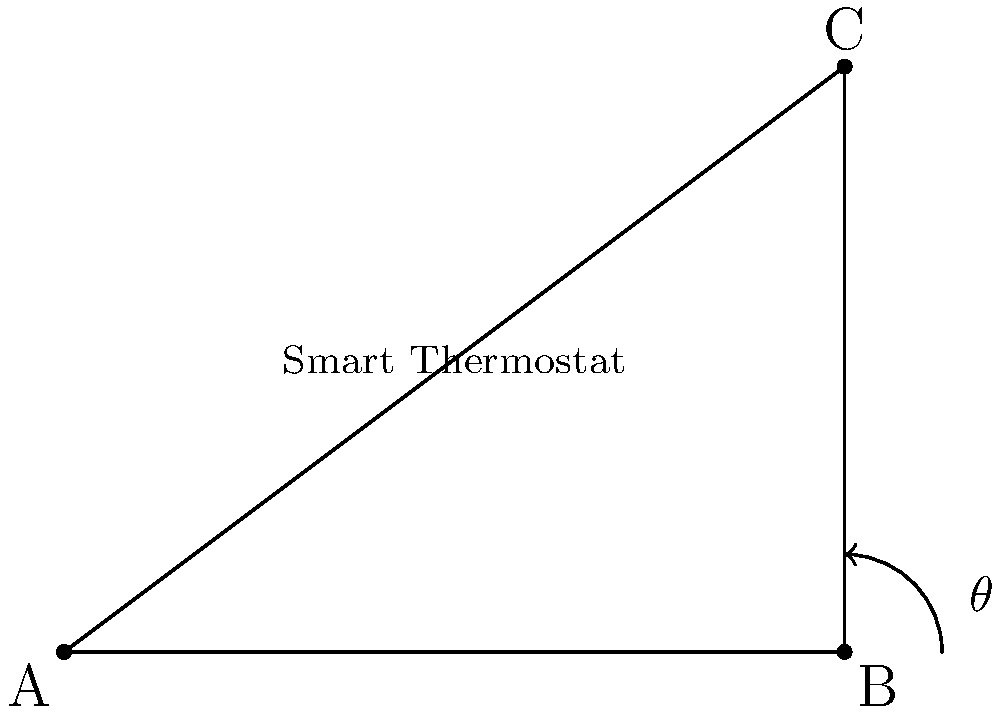In your shared apartment, a smart thermostat has been installed at the corner where two walls meet. If the walls form a right-angled corner and one wall is 3 meters long while the other is 4 meters long, what is the angle $\theta$ between these walls where the thermostat is placed? Let's approach this step-by-step:

1) The situation describes a right-angled triangle, where the two walls form two sides, and the angle we're looking for is at the corner.

2) We're given the lengths of both walls: 3 meters and 4 meters.

3) In a right-angled triangle, we can use the trigonometric function tangent (tan) to find an angle if we know the lengths of the opposite and adjacent sides.

4) The tangent of an angle is the ratio of the opposite side to the adjacent side.

5) Let's call our angle $\theta$. The wall that's 3 meters long is opposite to this angle, and the 4-meter wall is adjacent to it.

6) So, we can write: $\tan(\theta) = \frac{\text{opposite}}{\text{adjacent}} = \frac{3}{4}$

7) To find $\theta$, we need to take the inverse tangent (arctan or $\tan^{-1}$) of both sides:

   $\theta = \tan^{-1}(\frac{3}{4})$

8) Using a calculator or trigonometric tables, we can find that:

   $\theta \approx 36.87°$

Therefore, the angle between the two walls where the smart thermostat is installed is approximately 36.87°.
Answer: $36.87°$ 